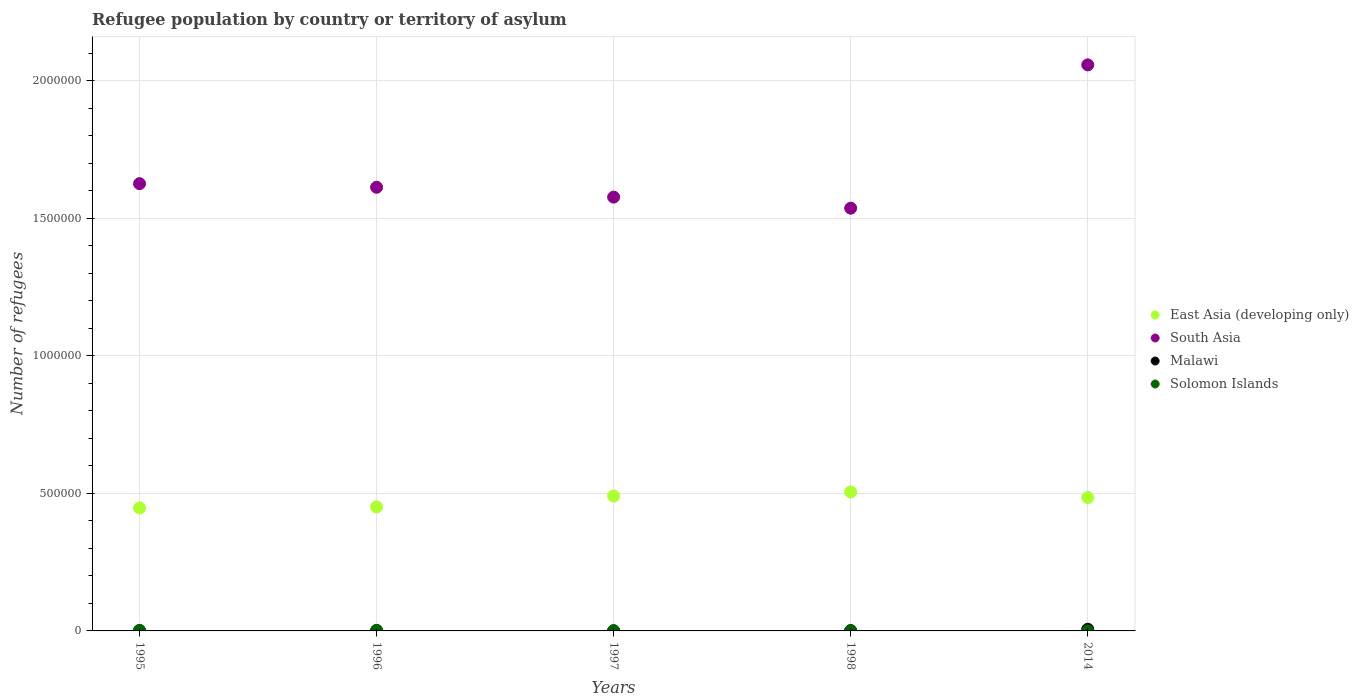What is the number of refugees in East Asia (developing only) in 1998?
Provide a succinct answer. 5.05e+05. Across all years, what is the maximum number of refugees in East Asia (developing only)?
Offer a very short reply. 5.05e+05. Across all years, what is the minimum number of refugees in East Asia (developing only)?
Provide a succinct answer. 4.47e+05. In which year was the number of refugees in South Asia minimum?
Keep it short and to the point. 1998. What is the total number of refugees in Solomon Islands in the graph?
Offer a terse response. 5013. What is the difference between the number of refugees in Malawi in 1996 and that in 1998?
Keep it short and to the point. 23. What is the difference between the number of refugees in Solomon Islands in 1995 and the number of refugees in East Asia (developing only) in 2014?
Ensure brevity in your answer.  -4.83e+05. What is the average number of refugees in East Asia (developing only) per year?
Keep it short and to the point. 4.76e+05. In the year 1998, what is the difference between the number of refugees in Malawi and number of refugees in South Asia?
Your answer should be compact. -1.54e+06. What is the ratio of the number of refugees in Malawi in 1996 to that in 1997?
Give a very brief answer. 4.53. Is the number of refugees in Malawi in 1995 less than that in 2014?
Give a very brief answer. Yes. What is the difference between the highest and the second highest number of refugees in Malawi?
Keep it short and to the point. 4606. What is the difference between the highest and the lowest number of refugees in Malawi?
Offer a terse response. 5594. In how many years, is the number of refugees in Solomon Islands greater than the average number of refugees in Solomon Islands taken over all years?
Give a very brief answer. 2. Is it the case that in every year, the sum of the number of refugees in Malawi and number of refugees in South Asia  is greater than the sum of number of refugees in East Asia (developing only) and number of refugees in Solomon Islands?
Offer a very short reply. No. Is the number of refugees in Solomon Islands strictly greater than the number of refugees in Malawi over the years?
Offer a very short reply. No. How many years are there in the graph?
Your answer should be compact. 5. Are the values on the major ticks of Y-axis written in scientific E-notation?
Your answer should be very brief. No. Where does the legend appear in the graph?
Offer a terse response. Center right. How many legend labels are there?
Your response must be concise. 4. What is the title of the graph?
Keep it short and to the point. Refugee population by country or territory of asylum. What is the label or title of the X-axis?
Provide a short and direct response. Years. What is the label or title of the Y-axis?
Provide a succinct answer. Number of refugees. What is the Number of refugees in East Asia (developing only) in 1995?
Provide a succinct answer. 4.47e+05. What is the Number of refugees of South Asia in 1995?
Provide a succinct answer. 1.63e+06. What is the Number of refugees of Malawi in 1995?
Keep it short and to the point. 1018. What is the Number of refugees of East Asia (developing only) in 1996?
Provide a short and direct response. 4.51e+05. What is the Number of refugees in South Asia in 1996?
Offer a terse response. 1.61e+06. What is the Number of refugees of Malawi in 1996?
Provide a short and direct response. 1268. What is the Number of refugees of Solomon Islands in 1996?
Offer a very short reply. 2000. What is the Number of refugees in East Asia (developing only) in 1997?
Provide a short and direct response. 4.90e+05. What is the Number of refugees of South Asia in 1997?
Your response must be concise. 1.58e+06. What is the Number of refugees of Malawi in 1997?
Keep it short and to the point. 280. What is the Number of refugees of Solomon Islands in 1997?
Make the answer very short. 800. What is the Number of refugees of East Asia (developing only) in 1998?
Give a very brief answer. 5.05e+05. What is the Number of refugees in South Asia in 1998?
Ensure brevity in your answer.  1.54e+06. What is the Number of refugees in Malawi in 1998?
Provide a succinct answer. 1245. What is the Number of refugees in Solomon Islands in 1998?
Your response must be concise. 210. What is the Number of refugees in East Asia (developing only) in 2014?
Make the answer very short. 4.85e+05. What is the Number of refugees of South Asia in 2014?
Provide a short and direct response. 2.06e+06. What is the Number of refugees of Malawi in 2014?
Ensure brevity in your answer.  5874. Across all years, what is the maximum Number of refugees in East Asia (developing only)?
Offer a terse response. 5.05e+05. Across all years, what is the maximum Number of refugees of South Asia?
Your answer should be very brief. 2.06e+06. Across all years, what is the maximum Number of refugees of Malawi?
Your answer should be very brief. 5874. Across all years, what is the minimum Number of refugees in East Asia (developing only)?
Offer a terse response. 4.47e+05. Across all years, what is the minimum Number of refugees of South Asia?
Offer a very short reply. 1.54e+06. Across all years, what is the minimum Number of refugees in Malawi?
Your response must be concise. 280. What is the total Number of refugees in East Asia (developing only) in the graph?
Make the answer very short. 2.38e+06. What is the total Number of refugees in South Asia in the graph?
Make the answer very short. 8.41e+06. What is the total Number of refugees of Malawi in the graph?
Provide a succinct answer. 9685. What is the total Number of refugees of Solomon Islands in the graph?
Ensure brevity in your answer.  5013. What is the difference between the Number of refugees in East Asia (developing only) in 1995 and that in 1996?
Provide a succinct answer. -3745. What is the difference between the Number of refugees in South Asia in 1995 and that in 1996?
Your response must be concise. 1.31e+04. What is the difference between the Number of refugees of Malawi in 1995 and that in 1996?
Make the answer very short. -250. What is the difference between the Number of refugees in East Asia (developing only) in 1995 and that in 1997?
Make the answer very short. -4.33e+04. What is the difference between the Number of refugees of South Asia in 1995 and that in 1997?
Give a very brief answer. 4.89e+04. What is the difference between the Number of refugees in Malawi in 1995 and that in 1997?
Offer a very short reply. 738. What is the difference between the Number of refugees of Solomon Islands in 1995 and that in 1997?
Keep it short and to the point. 1200. What is the difference between the Number of refugees in East Asia (developing only) in 1995 and that in 1998?
Ensure brevity in your answer.  -5.81e+04. What is the difference between the Number of refugees of South Asia in 1995 and that in 1998?
Offer a very short reply. 8.91e+04. What is the difference between the Number of refugees of Malawi in 1995 and that in 1998?
Keep it short and to the point. -227. What is the difference between the Number of refugees in Solomon Islands in 1995 and that in 1998?
Provide a short and direct response. 1790. What is the difference between the Number of refugees in East Asia (developing only) in 1995 and that in 2014?
Your response must be concise. -3.78e+04. What is the difference between the Number of refugees of South Asia in 1995 and that in 2014?
Ensure brevity in your answer.  -4.32e+05. What is the difference between the Number of refugees in Malawi in 1995 and that in 2014?
Make the answer very short. -4856. What is the difference between the Number of refugees in Solomon Islands in 1995 and that in 2014?
Your response must be concise. 1997. What is the difference between the Number of refugees in East Asia (developing only) in 1996 and that in 1997?
Provide a short and direct response. -3.96e+04. What is the difference between the Number of refugees in South Asia in 1996 and that in 1997?
Offer a very short reply. 3.58e+04. What is the difference between the Number of refugees in Malawi in 1996 and that in 1997?
Your answer should be very brief. 988. What is the difference between the Number of refugees of Solomon Islands in 1996 and that in 1997?
Ensure brevity in your answer.  1200. What is the difference between the Number of refugees in East Asia (developing only) in 1996 and that in 1998?
Offer a terse response. -5.44e+04. What is the difference between the Number of refugees of South Asia in 1996 and that in 1998?
Your response must be concise. 7.60e+04. What is the difference between the Number of refugees in Solomon Islands in 1996 and that in 1998?
Your answer should be very brief. 1790. What is the difference between the Number of refugees in East Asia (developing only) in 1996 and that in 2014?
Provide a short and direct response. -3.41e+04. What is the difference between the Number of refugees of South Asia in 1996 and that in 2014?
Give a very brief answer. -4.45e+05. What is the difference between the Number of refugees of Malawi in 1996 and that in 2014?
Provide a succinct answer. -4606. What is the difference between the Number of refugees of Solomon Islands in 1996 and that in 2014?
Your answer should be compact. 1997. What is the difference between the Number of refugees of East Asia (developing only) in 1997 and that in 1998?
Offer a terse response. -1.48e+04. What is the difference between the Number of refugees in South Asia in 1997 and that in 1998?
Give a very brief answer. 4.02e+04. What is the difference between the Number of refugees of Malawi in 1997 and that in 1998?
Offer a terse response. -965. What is the difference between the Number of refugees in Solomon Islands in 1997 and that in 1998?
Ensure brevity in your answer.  590. What is the difference between the Number of refugees of East Asia (developing only) in 1997 and that in 2014?
Ensure brevity in your answer.  5521. What is the difference between the Number of refugees in South Asia in 1997 and that in 2014?
Keep it short and to the point. -4.81e+05. What is the difference between the Number of refugees of Malawi in 1997 and that in 2014?
Keep it short and to the point. -5594. What is the difference between the Number of refugees of Solomon Islands in 1997 and that in 2014?
Your response must be concise. 797. What is the difference between the Number of refugees of East Asia (developing only) in 1998 and that in 2014?
Offer a terse response. 2.03e+04. What is the difference between the Number of refugees in South Asia in 1998 and that in 2014?
Your answer should be very brief. -5.21e+05. What is the difference between the Number of refugees in Malawi in 1998 and that in 2014?
Offer a very short reply. -4629. What is the difference between the Number of refugees of Solomon Islands in 1998 and that in 2014?
Your answer should be very brief. 207. What is the difference between the Number of refugees of East Asia (developing only) in 1995 and the Number of refugees of South Asia in 1996?
Offer a terse response. -1.17e+06. What is the difference between the Number of refugees of East Asia (developing only) in 1995 and the Number of refugees of Malawi in 1996?
Offer a very short reply. 4.46e+05. What is the difference between the Number of refugees in East Asia (developing only) in 1995 and the Number of refugees in Solomon Islands in 1996?
Offer a very short reply. 4.45e+05. What is the difference between the Number of refugees of South Asia in 1995 and the Number of refugees of Malawi in 1996?
Provide a short and direct response. 1.62e+06. What is the difference between the Number of refugees in South Asia in 1995 and the Number of refugees in Solomon Islands in 1996?
Your answer should be very brief. 1.62e+06. What is the difference between the Number of refugees of Malawi in 1995 and the Number of refugees of Solomon Islands in 1996?
Your answer should be compact. -982. What is the difference between the Number of refugees in East Asia (developing only) in 1995 and the Number of refugees in South Asia in 1997?
Provide a short and direct response. -1.13e+06. What is the difference between the Number of refugees in East Asia (developing only) in 1995 and the Number of refugees in Malawi in 1997?
Make the answer very short. 4.47e+05. What is the difference between the Number of refugees of East Asia (developing only) in 1995 and the Number of refugees of Solomon Islands in 1997?
Provide a short and direct response. 4.46e+05. What is the difference between the Number of refugees of South Asia in 1995 and the Number of refugees of Malawi in 1997?
Ensure brevity in your answer.  1.63e+06. What is the difference between the Number of refugees of South Asia in 1995 and the Number of refugees of Solomon Islands in 1997?
Give a very brief answer. 1.62e+06. What is the difference between the Number of refugees in Malawi in 1995 and the Number of refugees in Solomon Islands in 1997?
Make the answer very short. 218. What is the difference between the Number of refugees in East Asia (developing only) in 1995 and the Number of refugees in South Asia in 1998?
Provide a short and direct response. -1.09e+06. What is the difference between the Number of refugees in East Asia (developing only) in 1995 and the Number of refugees in Malawi in 1998?
Your answer should be compact. 4.46e+05. What is the difference between the Number of refugees in East Asia (developing only) in 1995 and the Number of refugees in Solomon Islands in 1998?
Make the answer very short. 4.47e+05. What is the difference between the Number of refugees of South Asia in 1995 and the Number of refugees of Malawi in 1998?
Your response must be concise. 1.62e+06. What is the difference between the Number of refugees of South Asia in 1995 and the Number of refugees of Solomon Islands in 1998?
Offer a very short reply. 1.63e+06. What is the difference between the Number of refugees in Malawi in 1995 and the Number of refugees in Solomon Islands in 1998?
Keep it short and to the point. 808. What is the difference between the Number of refugees of East Asia (developing only) in 1995 and the Number of refugees of South Asia in 2014?
Make the answer very short. -1.61e+06. What is the difference between the Number of refugees of East Asia (developing only) in 1995 and the Number of refugees of Malawi in 2014?
Make the answer very short. 4.41e+05. What is the difference between the Number of refugees in East Asia (developing only) in 1995 and the Number of refugees in Solomon Islands in 2014?
Provide a succinct answer. 4.47e+05. What is the difference between the Number of refugees in South Asia in 1995 and the Number of refugees in Malawi in 2014?
Your answer should be very brief. 1.62e+06. What is the difference between the Number of refugees of South Asia in 1995 and the Number of refugees of Solomon Islands in 2014?
Your response must be concise. 1.63e+06. What is the difference between the Number of refugees in Malawi in 1995 and the Number of refugees in Solomon Islands in 2014?
Make the answer very short. 1015. What is the difference between the Number of refugees of East Asia (developing only) in 1996 and the Number of refugees of South Asia in 1997?
Offer a very short reply. -1.13e+06. What is the difference between the Number of refugees in East Asia (developing only) in 1996 and the Number of refugees in Malawi in 1997?
Provide a short and direct response. 4.50e+05. What is the difference between the Number of refugees in East Asia (developing only) in 1996 and the Number of refugees in Solomon Islands in 1997?
Keep it short and to the point. 4.50e+05. What is the difference between the Number of refugees in South Asia in 1996 and the Number of refugees in Malawi in 1997?
Keep it short and to the point. 1.61e+06. What is the difference between the Number of refugees in South Asia in 1996 and the Number of refugees in Solomon Islands in 1997?
Offer a terse response. 1.61e+06. What is the difference between the Number of refugees of Malawi in 1996 and the Number of refugees of Solomon Islands in 1997?
Keep it short and to the point. 468. What is the difference between the Number of refugees in East Asia (developing only) in 1996 and the Number of refugees in South Asia in 1998?
Offer a terse response. -1.09e+06. What is the difference between the Number of refugees in East Asia (developing only) in 1996 and the Number of refugees in Malawi in 1998?
Provide a succinct answer. 4.49e+05. What is the difference between the Number of refugees of East Asia (developing only) in 1996 and the Number of refugees of Solomon Islands in 1998?
Your answer should be compact. 4.51e+05. What is the difference between the Number of refugees in South Asia in 1996 and the Number of refugees in Malawi in 1998?
Your response must be concise. 1.61e+06. What is the difference between the Number of refugees in South Asia in 1996 and the Number of refugees in Solomon Islands in 1998?
Make the answer very short. 1.61e+06. What is the difference between the Number of refugees of Malawi in 1996 and the Number of refugees of Solomon Islands in 1998?
Ensure brevity in your answer.  1058. What is the difference between the Number of refugees of East Asia (developing only) in 1996 and the Number of refugees of South Asia in 2014?
Give a very brief answer. -1.61e+06. What is the difference between the Number of refugees of East Asia (developing only) in 1996 and the Number of refugees of Malawi in 2014?
Ensure brevity in your answer.  4.45e+05. What is the difference between the Number of refugees of East Asia (developing only) in 1996 and the Number of refugees of Solomon Islands in 2014?
Your answer should be very brief. 4.51e+05. What is the difference between the Number of refugees in South Asia in 1996 and the Number of refugees in Malawi in 2014?
Your response must be concise. 1.61e+06. What is the difference between the Number of refugees of South Asia in 1996 and the Number of refugees of Solomon Islands in 2014?
Ensure brevity in your answer.  1.61e+06. What is the difference between the Number of refugees of Malawi in 1996 and the Number of refugees of Solomon Islands in 2014?
Keep it short and to the point. 1265. What is the difference between the Number of refugees in East Asia (developing only) in 1997 and the Number of refugees in South Asia in 1998?
Your answer should be very brief. -1.05e+06. What is the difference between the Number of refugees in East Asia (developing only) in 1997 and the Number of refugees in Malawi in 1998?
Provide a short and direct response. 4.89e+05. What is the difference between the Number of refugees in East Asia (developing only) in 1997 and the Number of refugees in Solomon Islands in 1998?
Your response must be concise. 4.90e+05. What is the difference between the Number of refugees in South Asia in 1997 and the Number of refugees in Malawi in 1998?
Provide a short and direct response. 1.58e+06. What is the difference between the Number of refugees of South Asia in 1997 and the Number of refugees of Solomon Islands in 1998?
Provide a short and direct response. 1.58e+06. What is the difference between the Number of refugees of Malawi in 1997 and the Number of refugees of Solomon Islands in 1998?
Provide a short and direct response. 70. What is the difference between the Number of refugees in East Asia (developing only) in 1997 and the Number of refugees in South Asia in 2014?
Your response must be concise. -1.57e+06. What is the difference between the Number of refugees in East Asia (developing only) in 1997 and the Number of refugees in Malawi in 2014?
Your response must be concise. 4.84e+05. What is the difference between the Number of refugees of East Asia (developing only) in 1997 and the Number of refugees of Solomon Islands in 2014?
Make the answer very short. 4.90e+05. What is the difference between the Number of refugees of South Asia in 1997 and the Number of refugees of Malawi in 2014?
Make the answer very short. 1.57e+06. What is the difference between the Number of refugees of South Asia in 1997 and the Number of refugees of Solomon Islands in 2014?
Offer a very short reply. 1.58e+06. What is the difference between the Number of refugees of Malawi in 1997 and the Number of refugees of Solomon Islands in 2014?
Offer a terse response. 277. What is the difference between the Number of refugees of East Asia (developing only) in 1998 and the Number of refugees of South Asia in 2014?
Your answer should be very brief. -1.55e+06. What is the difference between the Number of refugees of East Asia (developing only) in 1998 and the Number of refugees of Malawi in 2014?
Give a very brief answer. 4.99e+05. What is the difference between the Number of refugees of East Asia (developing only) in 1998 and the Number of refugees of Solomon Islands in 2014?
Make the answer very short. 5.05e+05. What is the difference between the Number of refugees of South Asia in 1998 and the Number of refugees of Malawi in 2014?
Keep it short and to the point. 1.53e+06. What is the difference between the Number of refugees of South Asia in 1998 and the Number of refugees of Solomon Islands in 2014?
Ensure brevity in your answer.  1.54e+06. What is the difference between the Number of refugees in Malawi in 1998 and the Number of refugees in Solomon Islands in 2014?
Your answer should be compact. 1242. What is the average Number of refugees in East Asia (developing only) per year?
Provide a short and direct response. 4.76e+05. What is the average Number of refugees of South Asia per year?
Provide a short and direct response. 1.68e+06. What is the average Number of refugees of Malawi per year?
Provide a succinct answer. 1937. What is the average Number of refugees of Solomon Islands per year?
Provide a succinct answer. 1002.6. In the year 1995, what is the difference between the Number of refugees of East Asia (developing only) and Number of refugees of South Asia?
Offer a terse response. -1.18e+06. In the year 1995, what is the difference between the Number of refugees in East Asia (developing only) and Number of refugees in Malawi?
Your answer should be compact. 4.46e+05. In the year 1995, what is the difference between the Number of refugees in East Asia (developing only) and Number of refugees in Solomon Islands?
Offer a terse response. 4.45e+05. In the year 1995, what is the difference between the Number of refugees of South Asia and Number of refugees of Malawi?
Provide a short and direct response. 1.62e+06. In the year 1995, what is the difference between the Number of refugees of South Asia and Number of refugees of Solomon Islands?
Keep it short and to the point. 1.62e+06. In the year 1995, what is the difference between the Number of refugees in Malawi and Number of refugees in Solomon Islands?
Your answer should be very brief. -982. In the year 1996, what is the difference between the Number of refugees in East Asia (developing only) and Number of refugees in South Asia?
Offer a terse response. -1.16e+06. In the year 1996, what is the difference between the Number of refugees in East Asia (developing only) and Number of refugees in Malawi?
Your answer should be very brief. 4.49e+05. In the year 1996, what is the difference between the Number of refugees of East Asia (developing only) and Number of refugees of Solomon Islands?
Your answer should be very brief. 4.49e+05. In the year 1996, what is the difference between the Number of refugees in South Asia and Number of refugees in Malawi?
Offer a very short reply. 1.61e+06. In the year 1996, what is the difference between the Number of refugees of South Asia and Number of refugees of Solomon Islands?
Provide a succinct answer. 1.61e+06. In the year 1996, what is the difference between the Number of refugees of Malawi and Number of refugees of Solomon Islands?
Give a very brief answer. -732. In the year 1997, what is the difference between the Number of refugees of East Asia (developing only) and Number of refugees of South Asia?
Give a very brief answer. -1.09e+06. In the year 1997, what is the difference between the Number of refugees in East Asia (developing only) and Number of refugees in Malawi?
Keep it short and to the point. 4.90e+05. In the year 1997, what is the difference between the Number of refugees in East Asia (developing only) and Number of refugees in Solomon Islands?
Provide a short and direct response. 4.90e+05. In the year 1997, what is the difference between the Number of refugees in South Asia and Number of refugees in Malawi?
Provide a short and direct response. 1.58e+06. In the year 1997, what is the difference between the Number of refugees in South Asia and Number of refugees in Solomon Islands?
Provide a short and direct response. 1.58e+06. In the year 1997, what is the difference between the Number of refugees in Malawi and Number of refugees in Solomon Islands?
Ensure brevity in your answer.  -520. In the year 1998, what is the difference between the Number of refugees of East Asia (developing only) and Number of refugees of South Asia?
Your answer should be very brief. -1.03e+06. In the year 1998, what is the difference between the Number of refugees in East Asia (developing only) and Number of refugees in Malawi?
Your answer should be very brief. 5.04e+05. In the year 1998, what is the difference between the Number of refugees of East Asia (developing only) and Number of refugees of Solomon Islands?
Keep it short and to the point. 5.05e+05. In the year 1998, what is the difference between the Number of refugees in South Asia and Number of refugees in Malawi?
Give a very brief answer. 1.54e+06. In the year 1998, what is the difference between the Number of refugees of South Asia and Number of refugees of Solomon Islands?
Your answer should be compact. 1.54e+06. In the year 1998, what is the difference between the Number of refugees of Malawi and Number of refugees of Solomon Islands?
Ensure brevity in your answer.  1035. In the year 2014, what is the difference between the Number of refugees in East Asia (developing only) and Number of refugees in South Asia?
Make the answer very short. -1.57e+06. In the year 2014, what is the difference between the Number of refugees of East Asia (developing only) and Number of refugees of Malawi?
Give a very brief answer. 4.79e+05. In the year 2014, what is the difference between the Number of refugees in East Asia (developing only) and Number of refugees in Solomon Islands?
Your answer should be very brief. 4.85e+05. In the year 2014, what is the difference between the Number of refugees in South Asia and Number of refugees in Malawi?
Give a very brief answer. 2.05e+06. In the year 2014, what is the difference between the Number of refugees of South Asia and Number of refugees of Solomon Islands?
Offer a terse response. 2.06e+06. In the year 2014, what is the difference between the Number of refugees of Malawi and Number of refugees of Solomon Islands?
Ensure brevity in your answer.  5871. What is the ratio of the Number of refugees in Malawi in 1995 to that in 1996?
Provide a short and direct response. 0.8. What is the ratio of the Number of refugees of East Asia (developing only) in 1995 to that in 1997?
Ensure brevity in your answer.  0.91. What is the ratio of the Number of refugees of South Asia in 1995 to that in 1997?
Offer a terse response. 1.03. What is the ratio of the Number of refugees in Malawi in 1995 to that in 1997?
Your answer should be compact. 3.64. What is the ratio of the Number of refugees in East Asia (developing only) in 1995 to that in 1998?
Provide a short and direct response. 0.89. What is the ratio of the Number of refugees of South Asia in 1995 to that in 1998?
Ensure brevity in your answer.  1.06. What is the ratio of the Number of refugees in Malawi in 1995 to that in 1998?
Give a very brief answer. 0.82. What is the ratio of the Number of refugees in Solomon Islands in 1995 to that in 1998?
Your response must be concise. 9.52. What is the ratio of the Number of refugees in East Asia (developing only) in 1995 to that in 2014?
Provide a succinct answer. 0.92. What is the ratio of the Number of refugees in South Asia in 1995 to that in 2014?
Your answer should be very brief. 0.79. What is the ratio of the Number of refugees in Malawi in 1995 to that in 2014?
Provide a short and direct response. 0.17. What is the ratio of the Number of refugees in Solomon Islands in 1995 to that in 2014?
Provide a short and direct response. 666.67. What is the ratio of the Number of refugees of East Asia (developing only) in 1996 to that in 1997?
Your answer should be very brief. 0.92. What is the ratio of the Number of refugees in South Asia in 1996 to that in 1997?
Ensure brevity in your answer.  1.02. What is the ratio of the Number of refugees of Malawi in 1996 to that in 1997?
Your answer should be very brief. 4.53. What is the ratio of the Number of refugees of Solomon Islands in 1996 to that in 1997?
Your response must be concise. 2.5. What is the ratio of the Number of refugees of East Asia (developing only) in 1996 to that in 1998?
Make the answer very short. 0.89. What is the ratio of the Number of refugees in South Asia in 1996 to that in 1998?
Your answer should be very brief. 1.05. What is the ratio of the Number of refugees in Malawi in 1996 to that in 1998?
Ensure brevity in your answer.  1.02. What is the ratio of the Number of refugees in Solomon Islands in 1996 to that in 1998?
Your response must be concise. 9.52. What is the ratio of the Number of refugees in East Asia (developing only) in 1996 to that in 2014?
Make the answer very short. 0.93. What is the ratio of the Number of refugees of South Asia in 1996 to that in 2014?
Your answer should be very brief. 0.78. What is the ratio of the Number of refugees in Malawi in 1996 to that in 2014?
Offer a terse response. 0.22. What is the ratio of the Number of refugees in Solomon Islands in 1996 to that in 2014?
Your answer should be compact. 666.67. What is the ratio of the Number of refugees in East Asia (developing only) in 1997 to that in 1998?
Keep it short and to the point. 0.97. What is the ratio of the Number of refugees of South Asia in 1997 to that in 1998?
Provide a short and direct response. 1.03. What is the ratio of the Number of refugees in Malawi in 1997 to that in 1998?
Ensure brevity in your answer.  0.22. What is the ratio of the Number of refugees in Solomon Islands in 1997 to that in 1998?
Offer a terse response. 3.81. What is the ratio of the Number of refugees of East Asia (developing only) in 1997 to that in 2014?
Provide a short and direct response. 1.01. What is the ratio of the Number of refugees of South Asia in 1997 to that in 2014?
Provide a short and direct response. 0.77. What is the ratio of the Number of refugees of Malawi in 1997 to that in 2014?
Your answer should be very brief. 0.05. What is the ratio of the Number of refugees in Solomon Islands in 1997 to that in 2014?
Keep it short and to the point. 266.67. What is the ratio of the Number of refugees of East Asia (developing only) in 1998 to that in 2014?
Give a very brief answer. 1.04. What is the ratio of the Number of refugees of South Asia in 1998 to that in 2014?
Make the answer very short. 0.75. What is the ratio of the Number of refugees of Malawi in 1998 to that in 2014?
Your response must be concise. 0.21. What is the difference between the highest and the second highest Number of refugees in East Asia (developing only)?
Provide a short and direct response. 1.48e+04. What is the difference between the highest and the second highest Number of refugees in South Asia?
Your response must be concise. 4.32e+05. What is the difference between the highest and the second highest Number of refugees of Malawi?
Offer a very short reply. 4606. What is the difference between the highest and the second highest Number of refugees in Solomon Islands?
Make the answer very short. 0. What is the difference between the highest and the lowest Number of refugees in East Asia (developing only)?
Make the answer very short. 5.81e+04. What is the difference between the highest and the lowest Number of refugees in South Asia?
Offer a very short reply. 5.21e+05. What is the difference between the highest and the lowest Number of refugees in Malawi?
Offer a very short reply. 5594. What is the difference between the highest and the lowest Number of refugees in Solomon Islands?
Offer a terse response. 1997. 